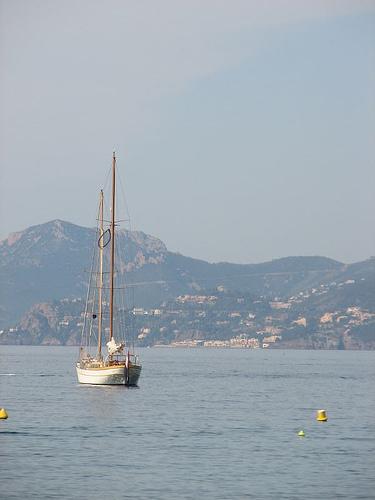Is the water calm?
Quick response, please. Yes. How many boats?
Short answer required. 1. What color is the buoy?
Concise answer only. Yellow. Does that boat have a flag?
Keep it brief. No. Is the sky clear?
Be succinct. No. How many sailboats are pictured?
Be succinct. 1. Is the boat in the center of the image a tug boat?
Short answer required. No. What propels the ship forward?
Concise answer only. Wind. Is this a hotel on the shore?
Concise answer only. No. What animal is shown?
Short answer required. None. Is the boat at dock?
Give a very brief answer. No. Is this a shipyard?
Write a very short answer. No. 